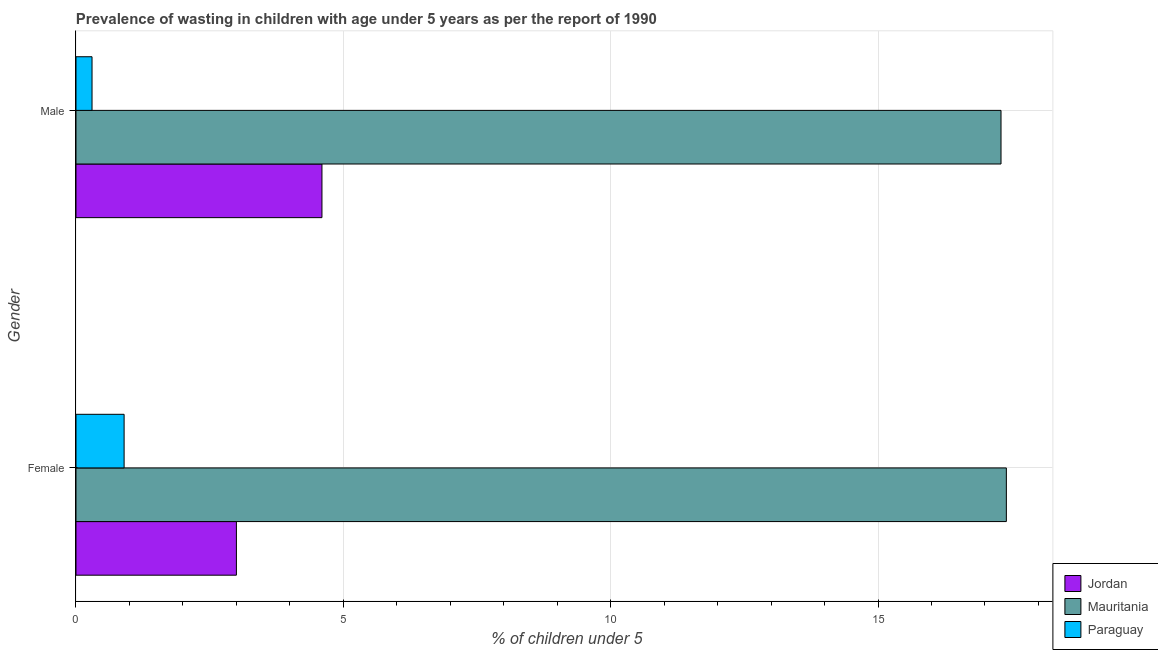Are the number of bars per tick equal to the number of legend labels?
Your response must be concise. Yes. Are the number of bars on each tick of the Y-axis equal?
Ensure brevity in your answer.  Yes. How many bars are there on the 1st tick from the bottom?
Offer a very short reply. 3. What is the label of the 2nd group of bars from the top?
Keep it short and to the point. Female. What is the percentage of undernourished male children in Paraguay?
Your answer should be very brief. 0.3. Across all countries, what is the maximum percentage of undernourished male children?
Give a very brief answer. 17.3. Across all countries, what is the minimum percentage of undernourished male children?
Ensure brevity in your answer.  0.3. In which country was the percentage of undernourished female children maximum?
Keep it short and to the point. Mauritania. In which country was the percentage of undernourished male children minimum?
Provide a succinct answer. Paraguay. What is the total percentage of undernourished female children in the graph?
Offer a terse response. 21.3. What is the difference between the percentage of undernourished male children in Mauritania and that in Paraguay?
Provide a succinct answer. 17. What is the difference between the percentage of undernourished female children in Paraguay and the percentage of undernourished male children in Mauritania?
Offer a terse response. -16.4. What is the average percentage of undernourished female children per country?
Offer a terse response. 7.1. What is the difference between the percentage of undernourished male children and percentage of undernourished female children in Paraguay?
Keep it short and to the point. -0.6. What is the ratio of the percentage of undernourished male children in Mauritania to that in Paraguay?
Offer a very short reply. 57.67. What does the 3rd bar from the top in Male represents?
Offer a terse response. Jordan. What does the 1st bar from the bottom in Male represents?
Give a very brief answer. Jordan. How many bars are there?
Offer a terse response. 6. What is the difference between two consecutive major ticks on the X-axis?
Offer a very short reply. 5. Are the values on the major ticks of X-axis written in scientific E-notation?
Make the answer very short. No. Does the graph contain grids?
Your answer should be compact. Yes. How are the legend labels stacked?
Offer a very short reply. Vertical. What is the title of the graph?
Your answer should be very brief. Prevalence of wasting in children with age under 5 years as per the report of 1990. Does "Mauritius" appear as one of the legend labels in the graph?
Keep it short and to the point. No. What is the label or title of the X-axis?
Your response must be concise.  % of children under 5. What is the label or title of the Y-axis?
Your answer should be compact. Gender. What is the  % of children under 5 of Jordan in Female?
Offer a terse response. 3. What is the  % of children under 5 of Mauritania in Female?
Offer a very short reply. 17.4. What is the  % of children under 5 in Paraguay in Female?
Make the answer very short. 0.9. What is the  % of children under 5 in Jordan in Male?
Your answer should be very brief. 4.6. What is the  % of children under 5 in Mauritania in Male?
Give a very brief answer. 17.3. What is the  % of children under 5 of Paraguay in Male?
Your response must be concise. 0.3. Across all Gender, what is the maximum  % of children under 5 of Jordan?
Your response must be concise. 4.6. Across all Gender, what is the maximum  % of children under 5 in Mauritania?
Your response must be concise. 17.4. Across all Gender, what is the maximum  % of children under 5 of Paraguay?
Ensure brevity in your answer.  0.9. Across all Gender, what is the minimum  % of children under 5 in Jordan?
Your response must be concise. 3. Across all Gender, what is the minimum  % of children under 5 in Mauritania?
Your response must be concise. 17.3. Across all Gender, what is the minimum  % of children under 5 of Paraguay?
Your answer should be very brief. 0.3. What is the total  % of children under 5 of Mauritania in the graph?
Provide a succinct answer. 34.7. What is the total  % of children under 5 in Paraguay in the graph?
Offer a terse response. 1.2. What is the difference between the  % of children under 5 of Jordan in Female and that in Male?
Keep it short and to the point. -1.6. What is the difference between the  % of children under 5 of Mauritania in Female and that in Male?
Your answer should be very brief. 0.1. What is the difference between the  % of children under 5 in Paraguay in Female and that in Male?
Offer a terse response. 0.6. What is the difference between the  % of children under 5 in Jordan in Female and the  % of children under 5 in Mauritania in Male?
Ensure brevity in your answer.  -14.3. What is the difference between the  % of children under 5 of Jordan in Female and the  % of children under 5 of Paraguay in Male?
Your answer should be very brief. 2.7. What is the difference between the  % of children under 5 in Mauritania in Female and the  % of children under 5 in Paraguay in Male?
Offer a very short reply. 17.1. What is the average  % of children under 5 in Mauritania per Gender?
Your answer should be compact. 17.35. What is the difference between the  % of children under 5 of Jordan and  % of children under 5 of Mauritania in Female?
Offer a terse response. -14.4. What is the ratio of the  % of children under 5 in Jordan in Female to that in Male?
Your answer should be compact. 0.65. What is the ratio of the  % of children under 5 of Paraguay in Female to that in Male?
Your answer should be compact. 3. What is the difference between the highest and the second highest  % of children under 5 of Paraguay?
Provide a succinct answer. 0.6. What is the difference between the highest and the lowest  % of children under 5 in Jordan?
Ensure brevity in your answer.  1.6. What is the difference between the highest and the lowest  % of children under 5 of Mauritania?
Keep it short and to the point. 0.1. 